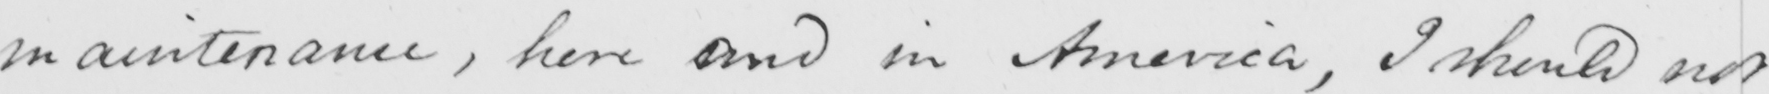What does this handwritten line say? maintenance , here and in America , I should not 